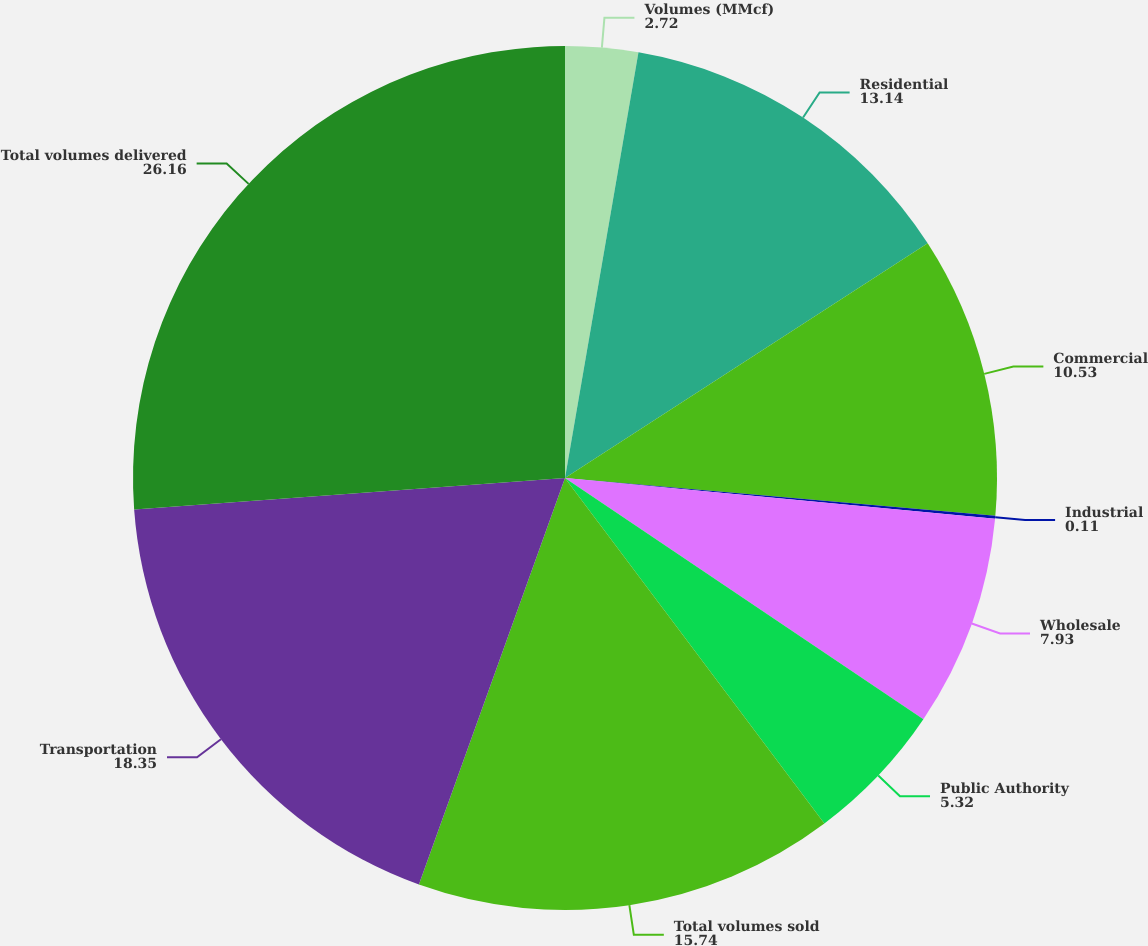Convert chart. <chart><loc_0><loc_0><loc_500><loc_500><pie_chart><fcel>Volumes (MMcf)<fcel>Residential<fcel>Commercial<fcel>Industrial<fcel>Wholesale<fcel>Public Authority<fcel>Total volumes sold<fcel>Transportation<fcel>Total volumes delivered<nl><fcel>2.72%<fcel>13.14%<fcel>10.53%<fcel>0.11%<fcel>7.93%<fcel>5.32%<fcel>15.74%<fcel>18.35%<fcel>26.16%<nl></chart> 